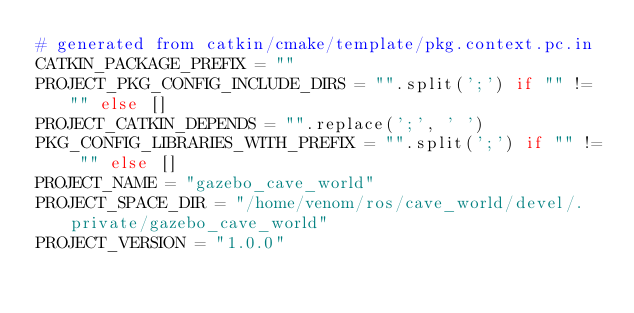<code> <loc_0><loc_0><loc_500><loc_500><_Python_># generated from catkin/cmake/template/pkg.context.pc.in
CATKIN_PACKAGE_PREFIX = ""
PROJECT_PKG_CONFIG_INCLUDE_DIRS = "".split(';') if "" != "" else []
PROJECT_CATKIN_DEPENDS = "".replace(';', ' ')
PKG_CONFIG_LIBRARIES_WITH_PREFIX = "".split(';') if "" != "" else []
PROJECT_NAME = "gazebo_cave_world"
PROJECT_SPACE_DIR = "/home/venom/ros/cave_world/devel/.private/gazebo_cave_world"
PROJECT_VERSION = "1.0.0"
</code> 